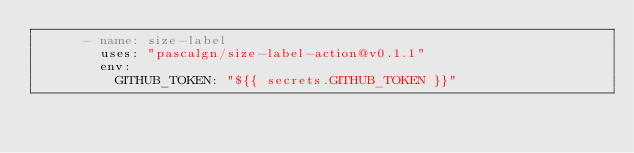Convert code to text. <code><loc_0><loc_0><loc_500><loc_500><_YAML_>      - name: size-label
        uses: "pascalgn/size-label-action@v0.1.1"
        env:
          GITHUB_TOKEN: "${{ secrets.GITHUB_TOKEN }}"
</code> 